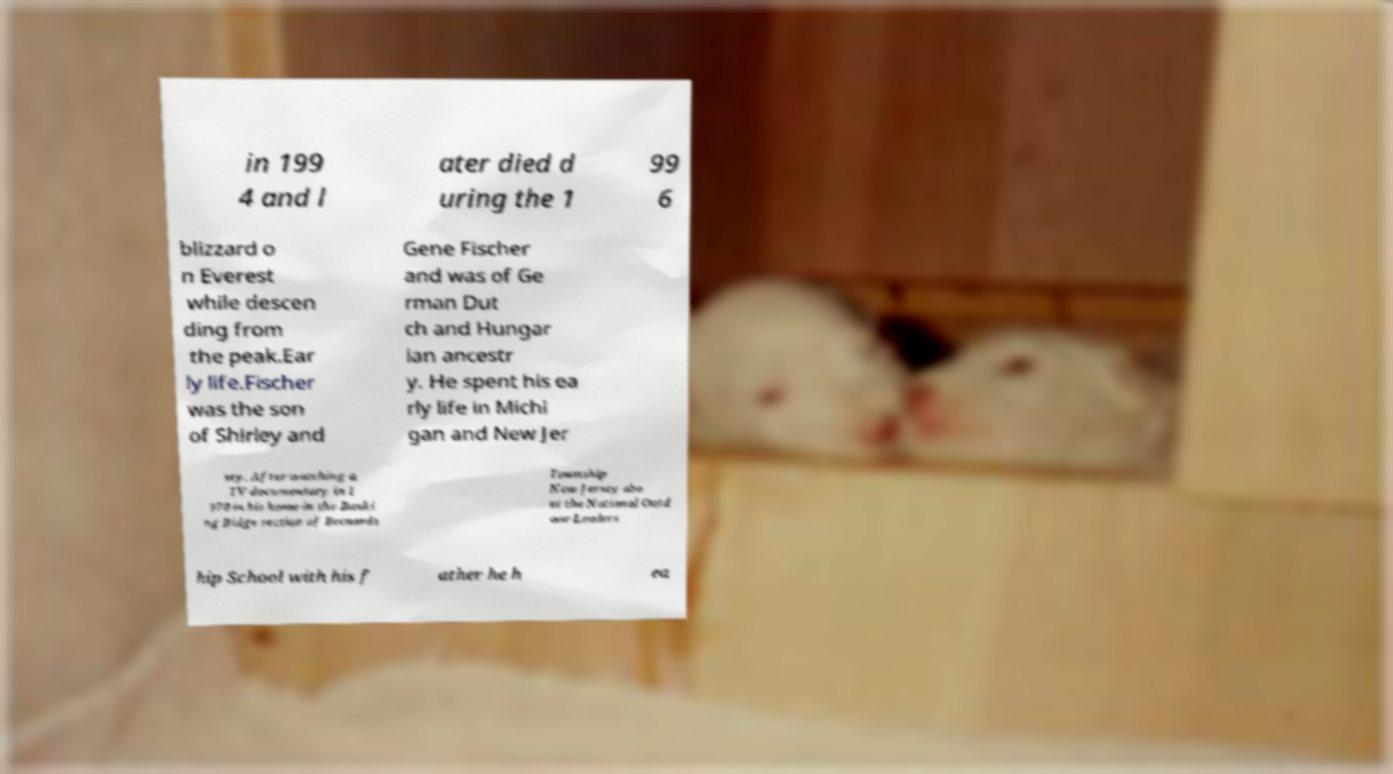There's text embedded in this image that I need extracted. Can you transcribe it verbatim? in 199 4 and l ater died d uring the 1 99 6 blizzard o n Everest while descen ding from the peak.Ear ly life.Fischer was the son of Shirley and Gene Fischer and was of Ge rman Dut ch and Hungar ian ancestr y. He spent his ea rly life in Michi gan and New Jer sey. After watching a TV documentary in 1 970 in his home in the Baski ng Ridge section of Bernards Township New Jersey abo ut the National Outd oor Leaders hip School with his f ather he h ea 